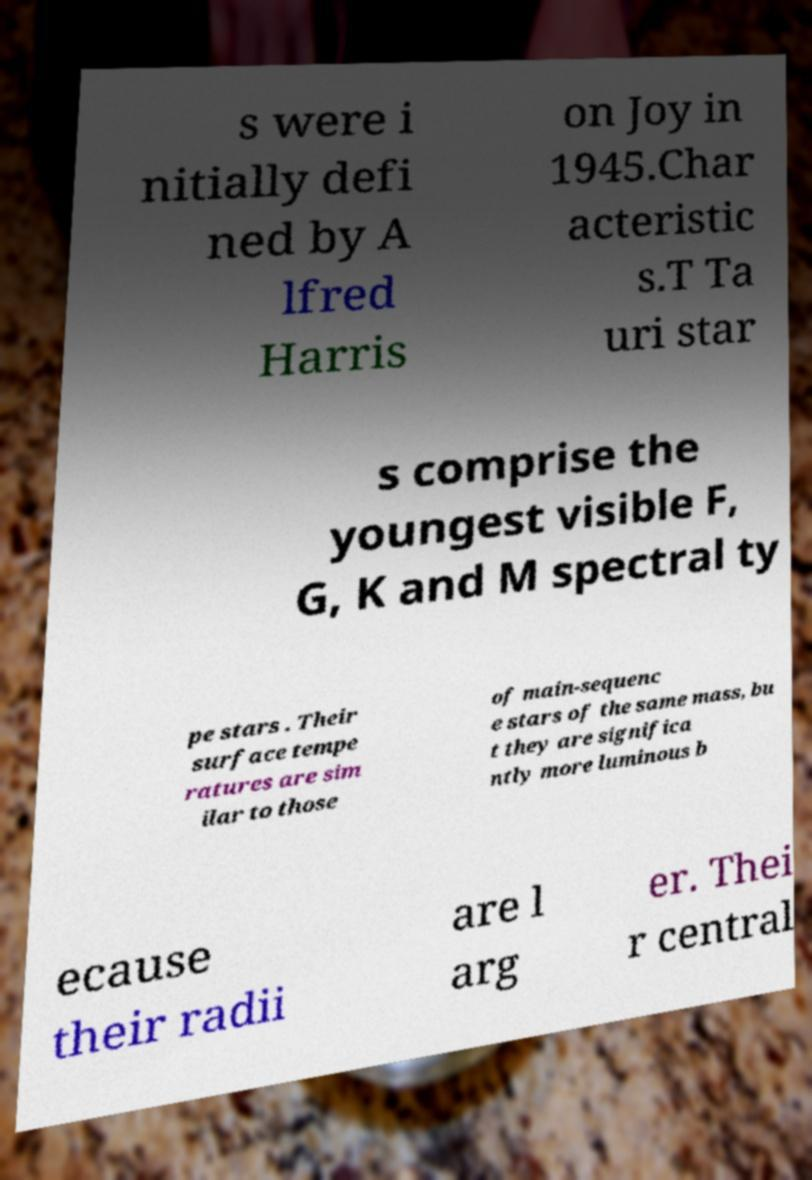For documentation purposes, I need the text within this image transcribed. Could you provide that? s were i nitially defi ned by A lfred Harris on Joy in 1945.Char acteristic s.T Ta uri star s comprise the youngest visible F, G, K and M spectral ty pe stars . Their surface tempe ratures are sim ilar to those of main-sequenc e stars of the same mass, bu t they are significa ntly more luminous b ecause their radii are l arg er. Thei r central 